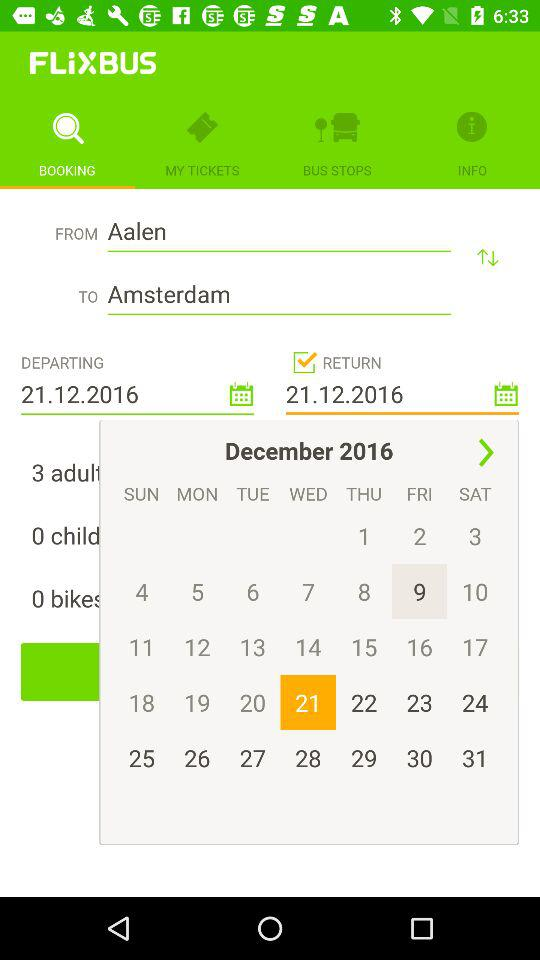What is the selected date? The selected date is Wednesday, December 21, 2016. 